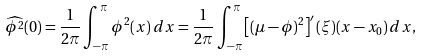Convert formula to latex. <formula><loc_0><loc_0><loc_500><loc_500>\widehat { \phi ^ { 2 } } ( 0 ) & = \frac { 1 } { 2 \pi } \int _ { - \pi } ^ { \pi } \phi ^ { 2 } ( x ) \, d x = \frac { 1 } { 2 \pi } \int _ { - \pi } ^ { \pi } \left [ ( \mu - \phi ) ^ { 2 } \right ] ^ { \prime } ( \xi ) ( x - x _ { 0 } ) \, d x ,</formula> 